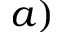<formula> <loc_0><loc_0><loc_500><loc_500>a )</formula> 